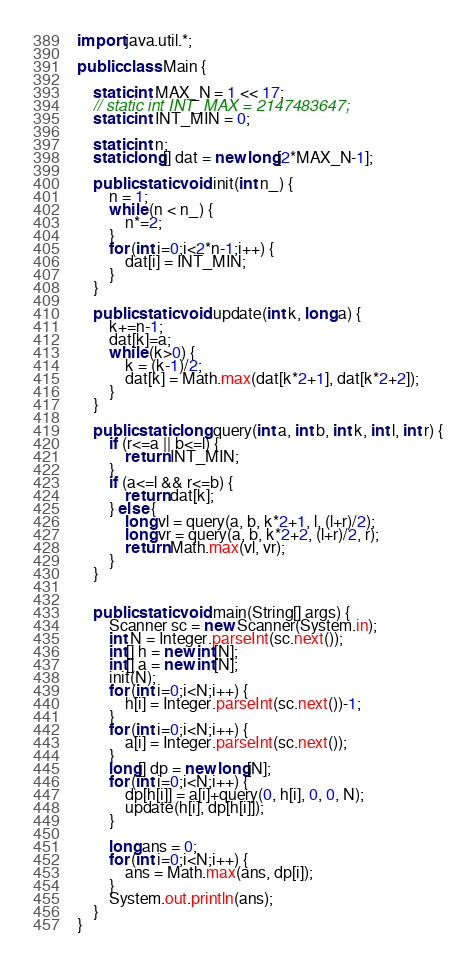Convert code to text. <code><loc_0><loc_0><loc_500><loc_500><_Java_>import java.util.*;

public class Main {

    static int MAX_N = 1 << 17;
    // static int INT_MAX = 2147483647;
    static int INT_MIN = 0;

    static int n;
    static long[] dat = new long[2*MAX_N-1];

    public static void init(int n_) {
        n = 1;
        while (n < n_) {
            n*=2;
        }
        for (int i=0;i<2*n-1;i++) {
            dat[i] = INT_MIN;
        }
    }

    public static void update(int k, long a) {
        k+=n-1;
        dat[k]=a;
        while (k>0) {
            k = (k-1)/2;
            dat[k] = Math.max(dat[k*2+1], dat[k*2+2]);
        }
    }

    public static long query(int a, int b, int k, int l, int r) {
        if (r<=a || b<=l) {
            return INT_MIN;
        }
        if (a<=l && r<=b) {
            return dat[k];
        } else {
            long vl = query(a, b, k*2+1, l, (l+r)/2);
            long vr = query(a, b, k*2+2, (l+r)/2, r);
            return Math.max(vl, vr);
        }
    }


    public static void main(String[] args) {
        Scanner sc = new Scanner(System.in);
        int N = Integer.parseInt(sc.next());
        int[] h = new int[N];
        int[] a = new int[N];
        init(N);
        for (int i=0;i<N;i++) {
            h[i] = Integer.parseInt(sc.next())-1;
        }
        for (int i=0;i<N;i++) {
            a[i] = Integer.parseInt(sc.next());
        }
        long[] dp = new long[N];
        for (int i=0;i<N;i++) {
            dp[h[i]] = a[i]+query(0, h[i], 0, 0, N);
            update(h[i], dp[h[i]]);
        }

        long ans = 0;
        for (int i=0;i<N;i++) {
            ans = Math.max(ans, dp[i]);
        }
        System.out.println(ans);
    }
}</code> 